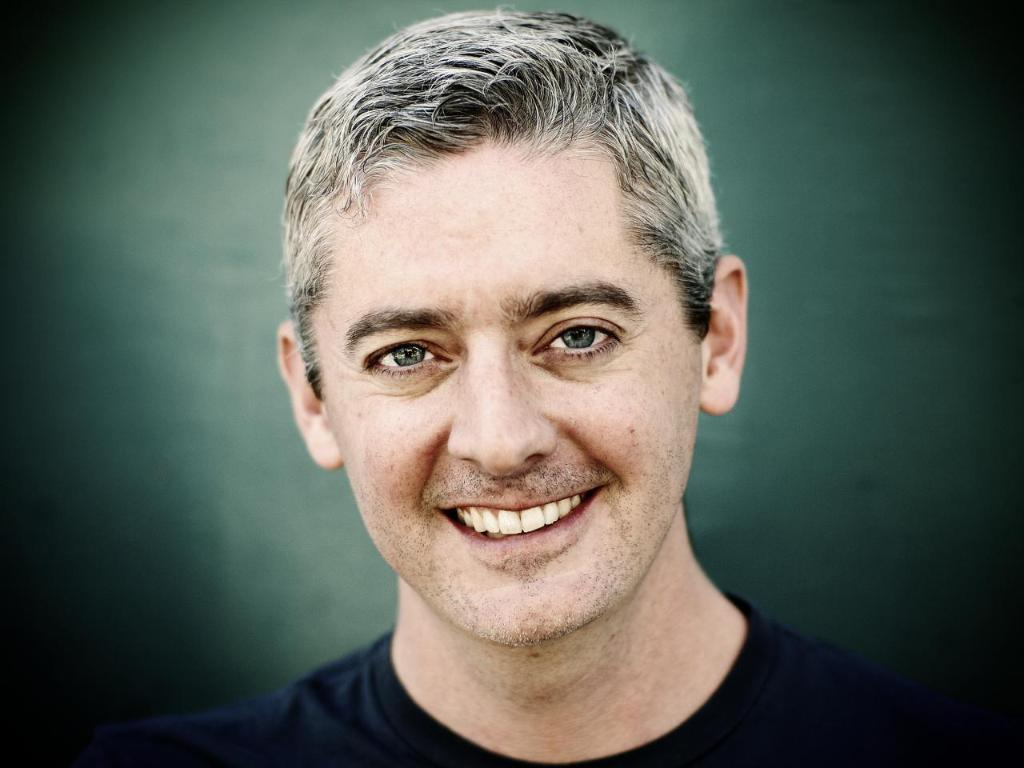Who is present in the image? There is a man in the image. What is the man doing in the image? The man is smiling in the image. What is the man wearing in the image? The man is wearing a black T-shirt in the image. What can be seen in the background of the image? The background of the image appears to be dark green in color. What type of structure is the chicken building in the image? There is no chicken or structure present in the image. 